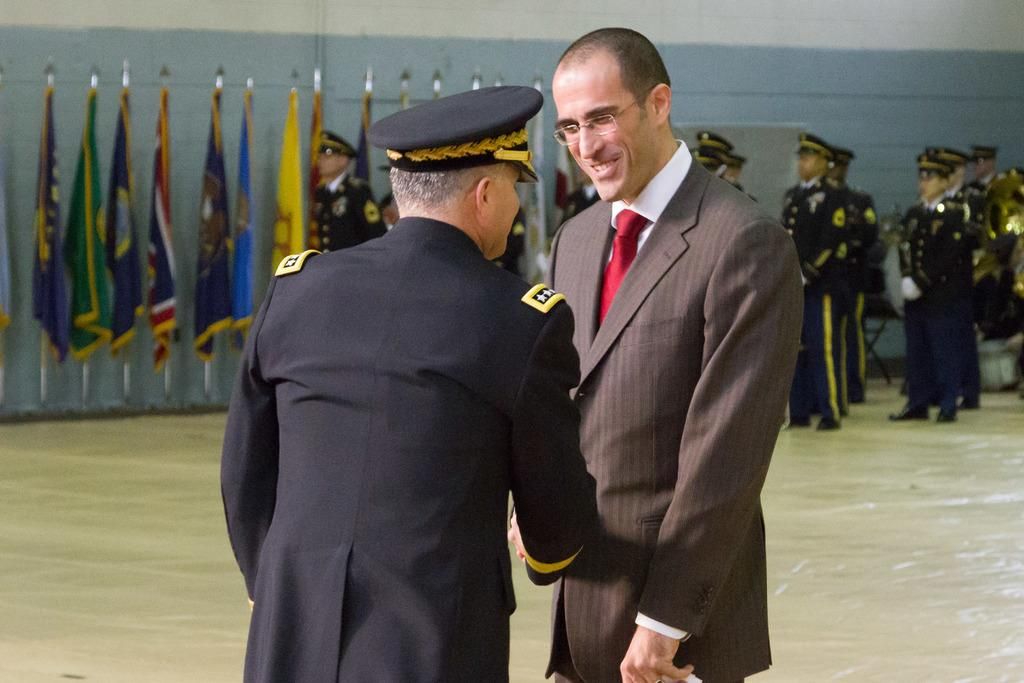How many men are present in the image? There are two men standing in the image. What can be seen hanging from poles in the image? Flags are hanging from poles in the image. Can you describe the group of people in the image? There is a group of people standing in the image. What type of structure can be seen in the image? There appears to be a wall in the image. Where is the sofa located in the image? There is no sofa present in the image. What type of memory is being shared by the group of people in the image? The image does not provide information about any shared memories among the group of people. 